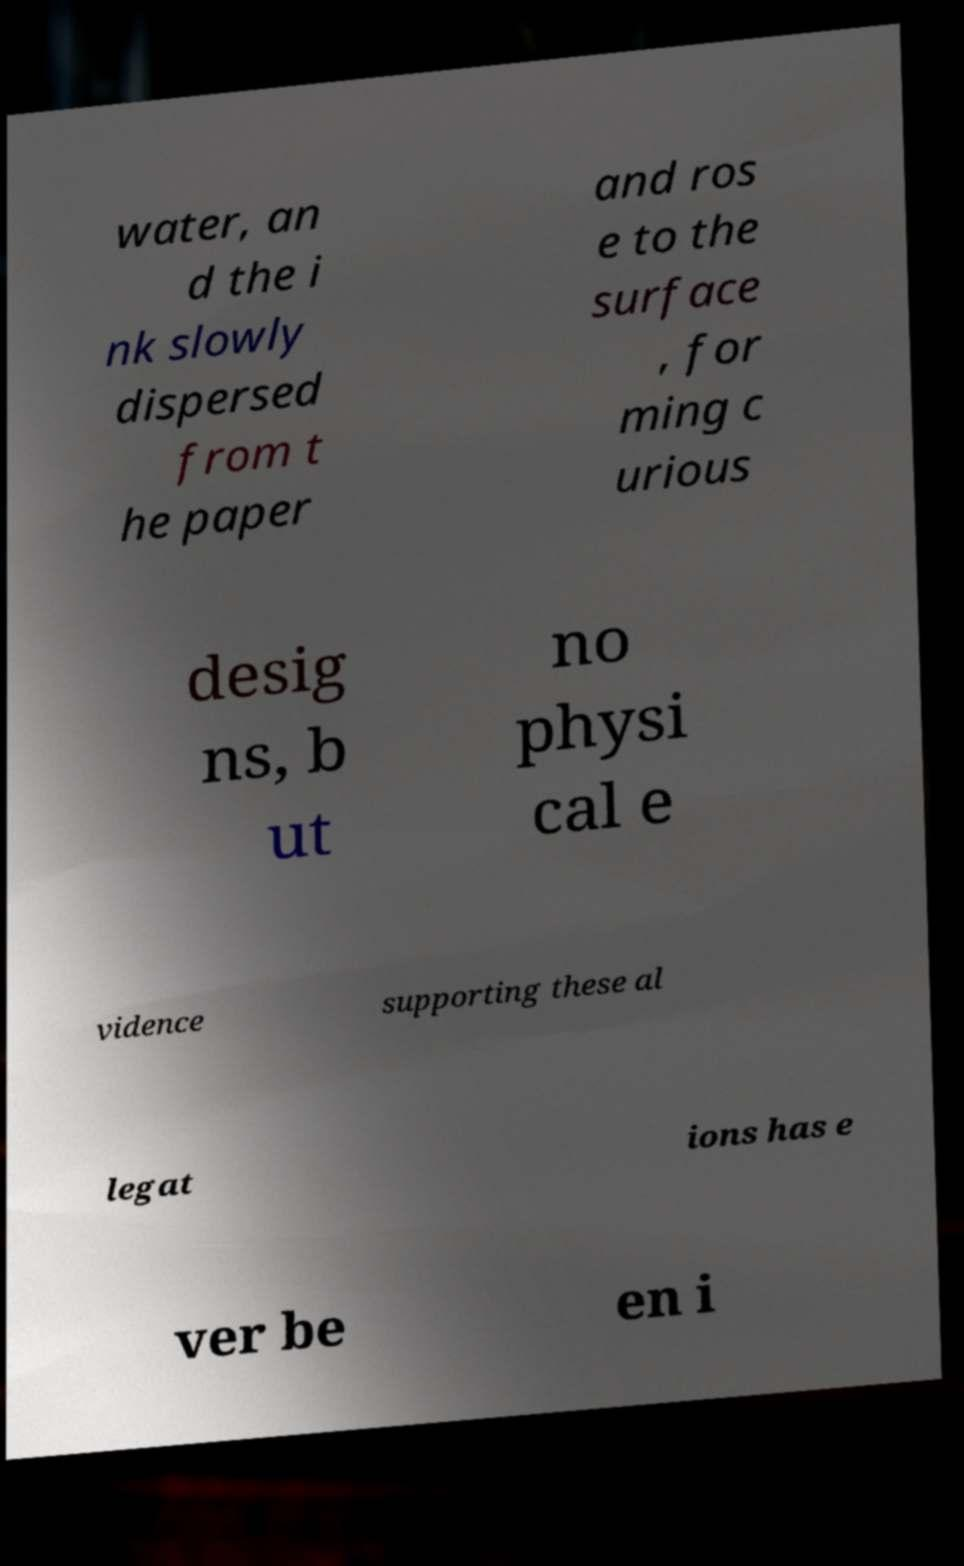I need the written content from this picture converted into text. Can you do that? water, an d the i nk slowly dispersed from t he paper and ros e to the surface , for ming c urious desig ns, b ut no physi cal e vidence supporting these al legat ions has e ver be en i 